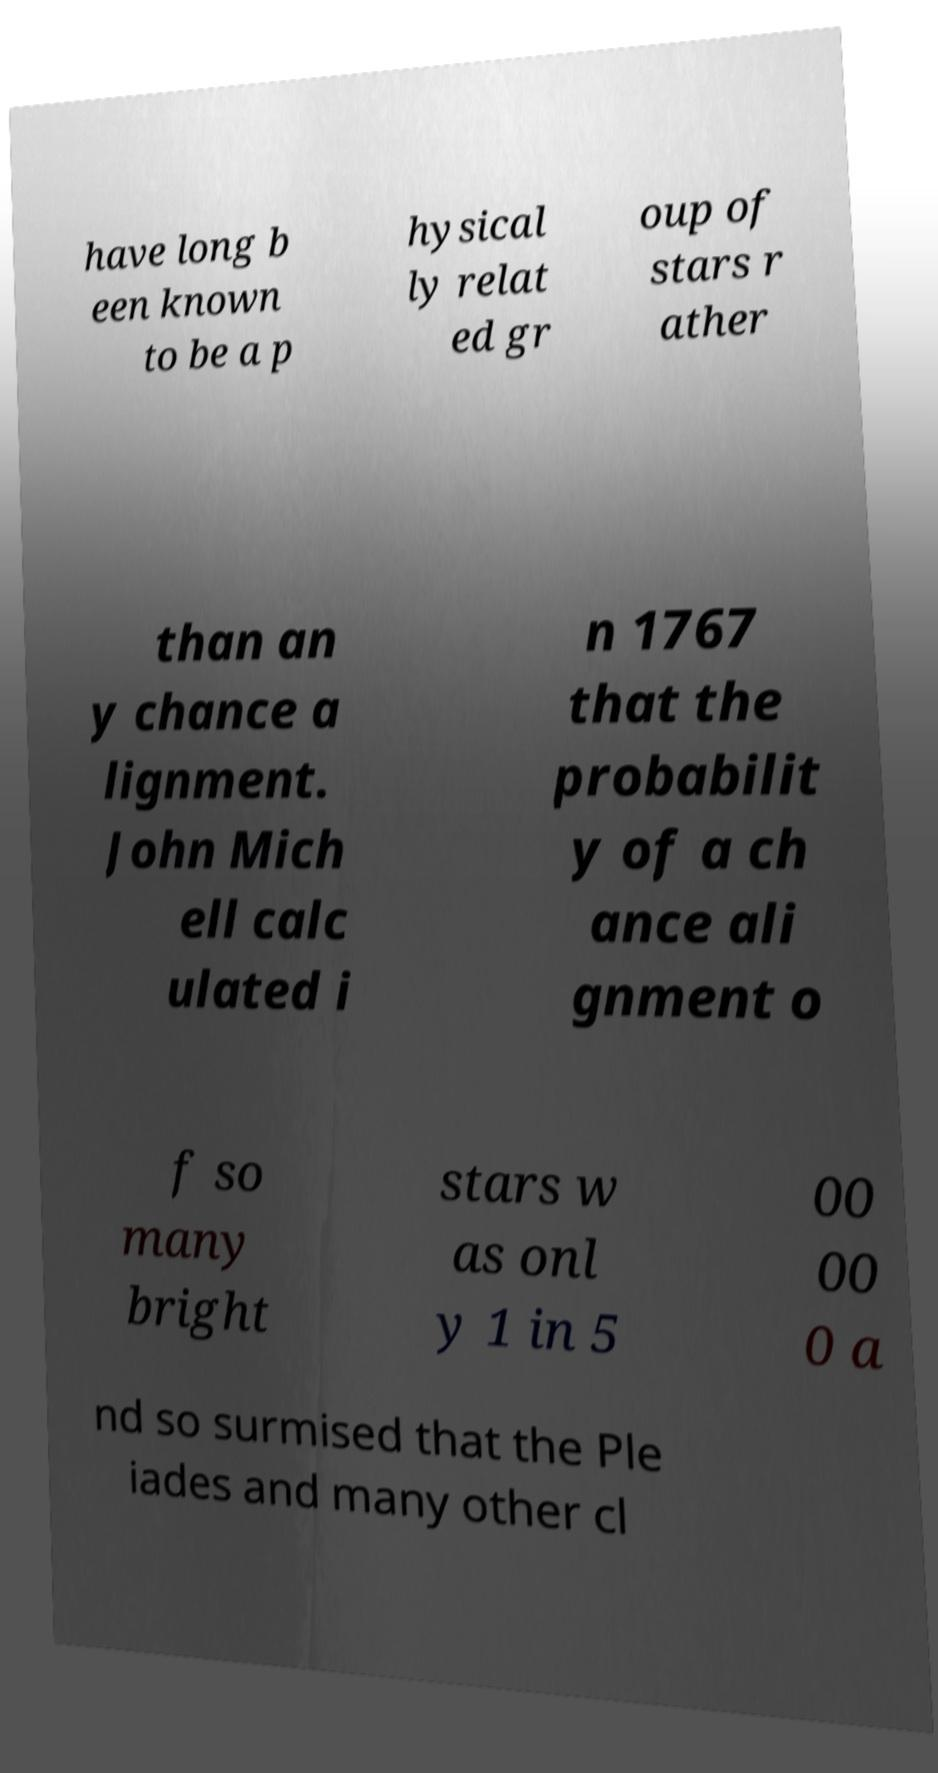Please read and relay the text visible in this image. What does it say? have long b een known to be a p hysical ly relat ed gr oup of stars r ather than an y chance a lignment. John Mich ell calc ulated i n 1767 that the probabilit y of a ch ance ali gnment o f so many bright stars w as onl y 1 in 5 00 00 0 a nd so surmised that the Ple iades and many other cl 